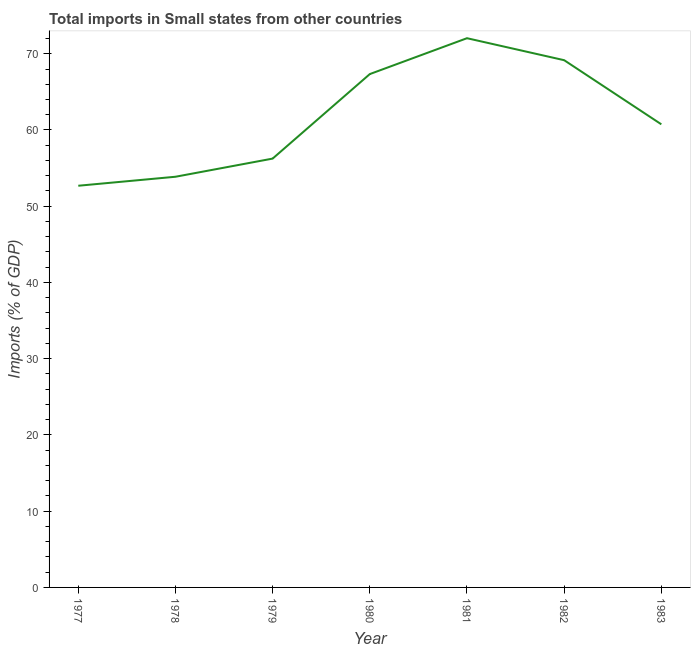What is the total imports in 1981?
Your answer should be very brief. 72.04. Across all years, what is the maximum total imports?
Your answer should be very brief. 72.04. Across all years, what is the minimum total imports?
Your answer should be very brief. 52.69. What is the sum of the total imports?
Keep it short and to the point. 432.08. What is the difference between the total imports in 1980 and 1981?
Provide a short and direct response. -4.71. What is the average total imports per year?
Your answer should be very brief. 61.73. What is the median total imports?
Give a very brief answer. 60.74. In how many years, is the total imports greater than 32 %?
Offer a very short reply. 7. Do a majority of the years between 1979 and 1977 (inclusive) have total imports greater than 20 %?
Offer a terse response. No. What is the ratio of the total imports in 1979 to that in 1983?
Give a very brief answer. 0.93. Is the total imports in 1977 less than that in 1980?
Your answer should be compact. Yes. What is the difference between the highest and the second highest total imports?
Provide a short and direct response. 2.88. What is the difference between the highest and the lowest total imports?
Offer a very short reply. 19.35. In how many years, is the total imports greater than the average total imports taken over all years?
Provide a short and direct response. 3. How many lines are there?
Offer a very short reply. 1. Are the values on the major ticks of Y-axis written in scientific E-notation?
Your answer should be very brief. No. Does the graph contain any zero values?
Your response must be concise. No. Does the graph contain grids?
Ensure brevity in your answer.  No. What is the title of the graph?
Your response must be concise. Total imports in Small states from other countries. What is the label or title of the Y-axis?
Make the answer very short. Imports (% of GDP). What is the Imports (% of GDP) in 1977?
Make the answer very short. 52.69. What is the Imports (% of GDP) of 1978?
Keep it short and to the point. 53.87. What is the Imports (% of GDP) in 1979?
Give a very brief answer. 56.25. What is the Imports (% of GDP) in 1980?
Make the answer very short. 67.33. What is the Imports (% of GDP) in 1981?
Keep it short and to the point. 72.04. What is the Imports (% of GDP) of 1982?
Keep it short and to the point. 69.16. What is the Imports (% of GDP) of 1983?
Make the answer very short. 60.74. What is the difference between the Imports (% of GDP) in 1977 and 1978?
Keep it short and to the point. -1.18. What is the difference between the Imports (% of GDP) in 1977 and 1979?
Provide a succinct answer. -3.56. What is the difference between the Imports (% of GDP) in 1977 and 1980?
Your answer should be very brief. -14.65. What is the difference between the Imports (% of GDP) in 1977 and 1981?
Your answer should be very brief. -19.35. What is the difference between the Imports (% of GDP) in 1977 and 1982?
Make the answer very short. -16.47. What is the difference between the Imports (% of GDP) in 1977 and 1983?
Your answer should be very brief. -8.06. What is the difference between the Imports (% of GDP) in 1978 and 1979?
Your answer should be very brief. -2.38. What is the difference between the Imports (% of GDP) in 1978 and 1980?
Offer a terse response. -13.47. What is the difference between the Imports (% of GDP) in 1978 and 1981?
Offer a very short reply. -18.17. What is the difference between the Imports (% of GDP) in 1978 and 1982?
Ensure brevity in your answer.  -15.29. What is the difference between the Imports (% of GDP) in 1978 and 1983?
Make the answer very short. -6.88. What is the difference between the Imports (% of GDP) in 1979 and 1980?
Keep it short and to the point. -11.09. What is the difference between the Imports (% of GDP) in 1979 and 1981?
Make the answer very short. -15.79. What is the difference between the Imports (% of GDP) in 1979 and 1982?
Offer a very short reply. -12.91. What is the difference between the Imports (% of GDP) in 1979 and 1983?
Keep it short and to the point. -4.49. What is the difference between the Imports (% of GDP) in 1980 and 1981?
Offer a terse response. -4.71. What is the difference between the Imports (% of GDP) in 1980 and 1982?
Give a very brief answer. -1.82. What is the difference between the Imports (% of GDP) in 1980 and 1983?
Offer a very short reply. 6.59. What is the difference between the Imports (% of GDP) in 1981 and 1982?
Offer a terse response. 2.88. What is the difference between the Imports (% of GDP) in 1981 and 1983?
Your answer should be very brief. 11.3. What is the difference between the Imports (% of GDP) in 1982 and 1983?
Give a very brief answer. 8.41. What is the ratio of the Imports (% of GDP) in 1977 to that in 1978?
Keep it short and to the point. 0.98. What is the ratio of the Imports (% of GDP) in 1977 to that in 1979?
Offer a terse response. 0.94. What is the ratio of the Imports (% of GDP) in 1977 to that in 1980?
Your response must be concise. 0.78. What is the ratio of the Imports (% of GDP) in 1977 to that in 1981?
Offer a terse response. 0.73. What is the ratio of the Imports (% of GDP) in 1977 to that in 1982?
Provide a succinct answer. 0.76. What is the ratio of the Imports (% of GDP) in 1977 to that in 1983?
Your answer should be compact. 0.87. What is the ratio of the Imports (% of GDP) in 1978 to that in 1979?
Your answer should be very brief. 0.96. What is the ratio of the Imports (% of GDP) in 1978 to that in 1980?
Provide a succinct answer. 0.8. What is the ratio of the Imports (% of GDP) in 1978 to that in 1981?
Offer a terse response. 0.75. What is the ratio of the Imports (% of GDP) in 1978 to that in 1982?
Offer a very short reply. 0.78. What is the ratio of the Imports (% of GDP) in 1978 to that in 1983?
Give a very brief answer. 0.89. What is the ratio of the Imports (% of GDP) in 1979 to that in 1980?
Provide a succinct answer. 0.83. What is the ratio of the Imports (% of GDP) in 1979 to that in 1981?
Keep it short and to the point. 0.78. What is the ratio of the Imports (% of GDP) in 1979 to that in 1982?
Give a very brief answer. 0.81. What is the ratio of the Imports (% of GDP) in 1979 to that in 1983?
Your response must be concise. 0.93. What is the ratio of the Imports (% of GDP) in 1980 to that in 1981?
Your answer should be compact. 0.94. What is the ratio of the Imports (% of GDP) in 1980 to that in 1983?
Your answer should be compact. 1.11. What is the ratio of the Imports (% of GDP) in 1981 to that in 1982?
Ensure brevity in your answer.  1.04. What is the ratio of the Imports (% of GDP) in 1981 to that in 1983?
Ensure brevity in your answer.  1.19. What is the ratio of the Imports (% of GDP) in 1982 to that in 1983?
Provide a short and direct response. 1.14. 